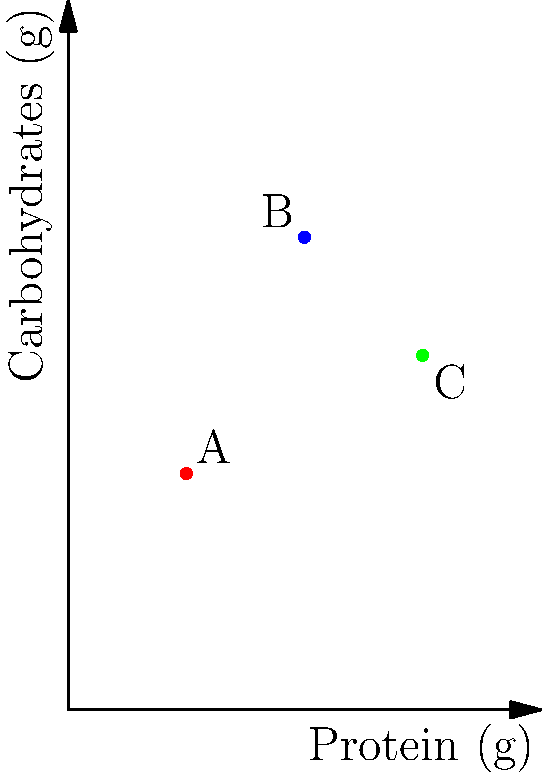In a study examining the effects of macronutrient intake on gene expression in athletes, three different dietary interventions (A, B, and C) were tested. The graph shows the protein and carbohydrate content of each intervention. Which intervention has the highest protein-to-carbohydrate ratio? To determine which intervention has the highest protein-to-carbohydrate ratio, we need to calculate the ratio for each intervention and compare them:

1. Intervention A: 
   Protein: 50g, Carbohydrates: 100g
   Ratio = 50/100 = 0.5

2. Intervention B:
   Protein: 100g, Carbohydrates: 200g
   Ratio = 100/200 = 0.5

3. Intervention C:
   Protein: 150g, Carbohydrates: 150g
   Ratio = 150/150 = 1

Comparing the ratios:
A: 0.5
B: 0.5
C: 1

Intervention C has the highest protein-to-carbohydrate ratio at 1:1.
Answer: C 